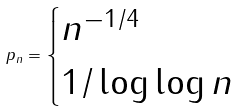<formula> <loc_0><loc_0><loc_500><loc_500>p _ { n } = \begin{cases} n ^ { - 1 / 4 } & \\ 1 / \log \log n & \end{cases}</formula> 